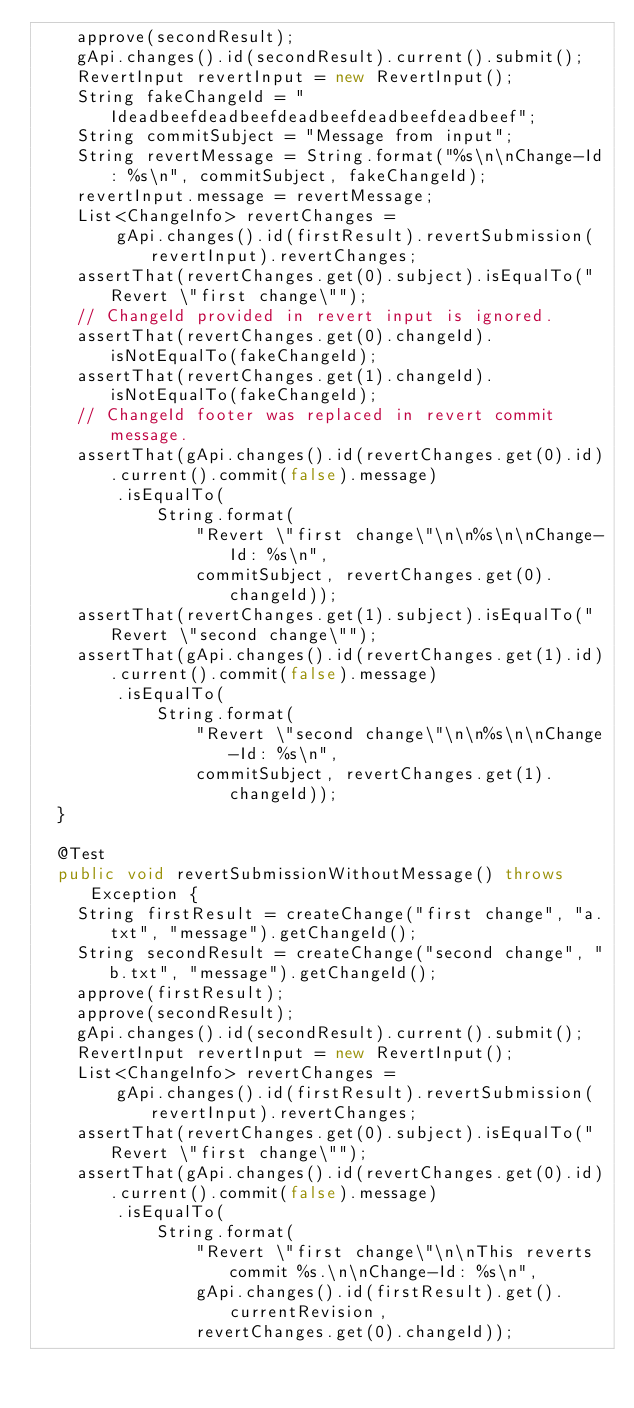Convert code to text. <code><loc_0><loc_0><loc_500><loc_500><_Java_>    approve(secondResult);
    gApi.changes().id(secondResult).current().submit();
    RevertInput revertInput = new RevertInput();
    String fakeChangeId = "Ideadbeefdeadbeefdeadbeefdeadbeefdeadbeef";
    String commitSubject = "Message from input";
    String revertMessage = String.format("%s\n\nChange-Id: %s\n", commitSubject, fakeChangeId);
    revertInput.message = revertMessage;
    List<ChangeInfo> revertChanges =
        gApi.changes().id(firstResult).revertSubmission(revertInput).revertChanges;
    assertThat(revertChanges.get(0).subject).isEqualTo("Revert \"first change\"");
    // ChangeId provided in revert input is ignored.
    assertThat(revertChanges.get(0).changeId).isNotEqualTo(fakeChangeId);
    assertThat(revertChanges.get(1).changeId).isNotEqualTo(fakeChangeId);
    // ChangeId footer was replaced in revert commit message.
    assertThat(gApi.changes().id(revertChanges.get(0).id).current().commit(false).message)
        .isEqualTo(
            String.format(
                "Revert \"first change\"\n\n%s\n\nChange-Id: %s\n",
                commitSubject, revertChanges.get(0).changeId));
    assertThat(revertChanges.get(1).subject).isEqualTo("Revert \"second change\"");
    assertThat(gApi.changes().id(revertChanges.get(1).id).current().commit(false).message)
        .isEqualTo(
            String.format(
                "Revert \"second change\"\n\n%s\n\nChange-Id: %s\n",
                commitSubject, revertChanges.get(1).changeId));
  }

  @Test
  public void revertSubmissionWithoutMessage() throws Exception {
    String firstResult = createChange("first change", "a.txt", "message").getChangeId();
    String secondResult = createChange("second change", "b.txt", "message").getChangeId();
    approve(firstResult);
    approve(secondResult);
    gApi.changes().id(secondResult).current().submit();
    RevertInput revertInput = new RevertInput();
    List<ChangeInfo> revertChanges =
        gApi.changes().id(firstResult).revertSubmission(revertInput).revertChanges;
    assertThat(revertChanges.get(0).subject).isEqualTo("Revert \"first change\"");
    assertThat(gApi.changes().id(revertChanges.get(0).id).current().commit(false).message)
        .isEqualTo(
            String.format(
                "Revert \"first change\"\n\nThis reverts commit %s.\n\nChange-Id: %s\n",
                gApi.changes().id(firstResult).get().currentRevision,
                revertChanges.get(0).changeId));</code> 